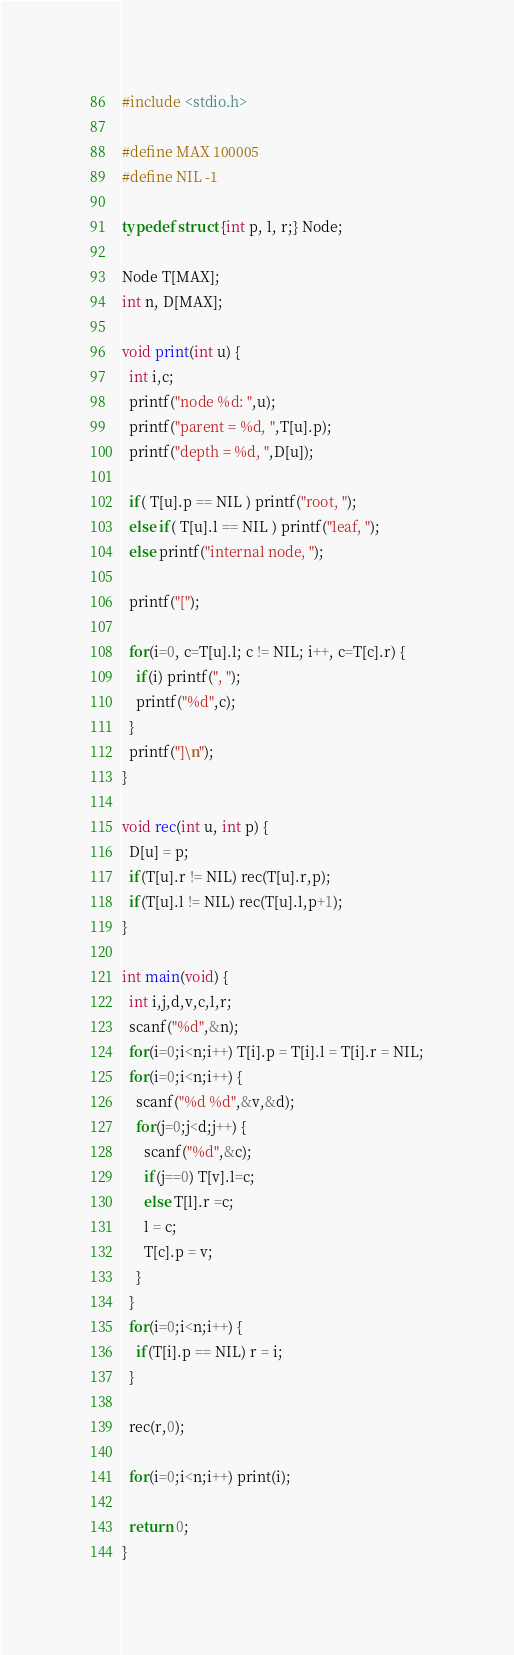Convert code to text. <code><loc_0><loc_0><loc_500><loc_500><_C_>
#include <stdio.h>

#define MAX 100005
#define NIL -1

typedef struct {int p, l, r;} Node;

Node T[MAX];
int n, D[MAX];

void print(int u) {
  int i,c;
  printf("node %d: ",u);
  printf("parent = %d, ",T[u].p);
  printf("depth = %d, ",D[u]);

  if( T[u].p == NIL ) printf("root, ");
  else if( T[u].l == NIL ) printf("leaf, ");
  else printf("internal node, ");

  printf("[");

  for(i=0, c=T[u].l; c != NIL; i++, c=T[c].r) {
    if(i) printf(", ");
    printf("%d",c);
  }
  printf("]\n");
}

void rec(int u, int p) {
  D[u] = p;
  if(T[u].r != NIL) rec(T[u].r,p);
  if(T[u].l != NIL) rec(T[u].l,p+1);
}

int main(void) {
  int i,j,d,v,c,l,r;
  scanf("%d",&n);
  for(i=0;i<n;i++) T[i].p = T[i].l = T[i].r = NIL;
  for(i=0;i<n;i++) {
    scanf("%d %d",&v,&d);
    for(j=0;j<d;j++) {
      scanf("%d",&c);
      if(j==0) T[v].l=c;
      else T[l].r =c;
      l = c;
      T[c].p = v;
    }
  }
  for(i=0;i<n;i++) {
    if(T[i].p == NIL) r = i;
  }
  
  rec(r,0);
  
  for(i=0;i<n;i++) print(i);
  
  return 0;
}

</code> 